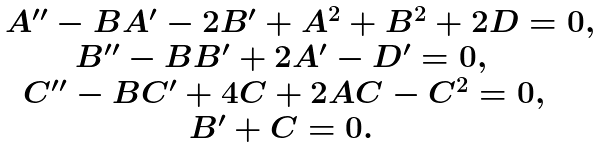<formula> <loc_0><loc_0><loc_500><loc_500>\begin{matrix} A ^ { \prime \prime } - B A ^ { \prime } - 2 B ^ { \prime } + A ^ { 2 } + B ^ { 2 } + 2 D = 0 , \\ B ^ { \prime \prime } - B B ^ { \prime } + 2 A ^ { \prime } - D ^ { \prime } = 0 , \quad \, \\ C ^ { \prime \prime } - B C ^ { \prime } + 4 C + 2 A C - C ^ { 2 } = 0 , \quad \\ B ^ { \prime } + C = 0 . \quad \, \end{matrix}</formula> 